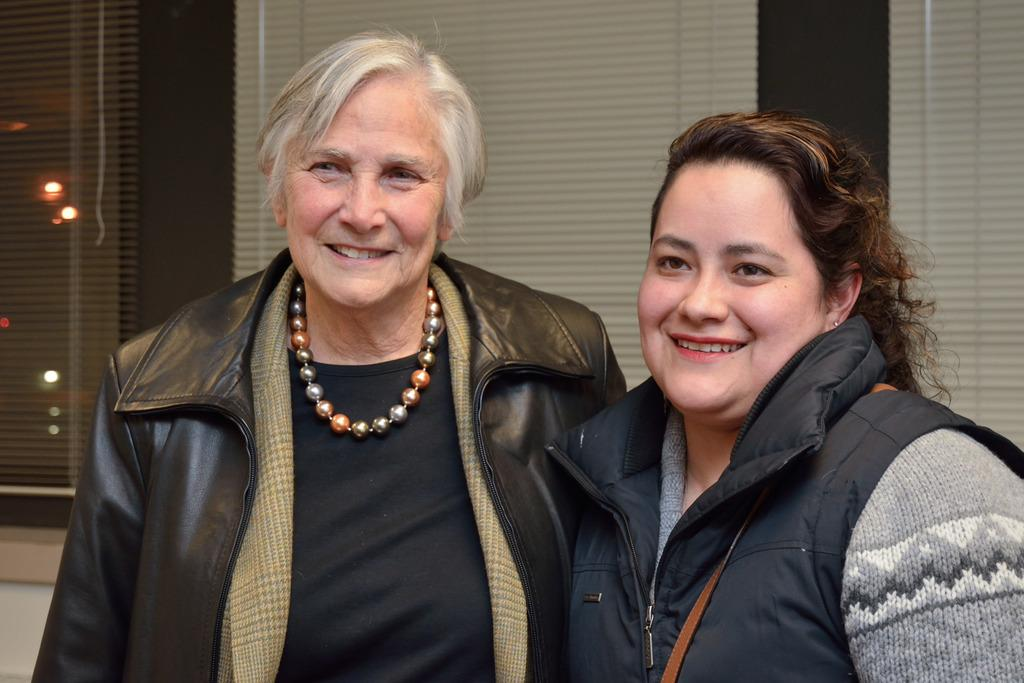How many people are in the image? There are two people in the image. What are the people doing in the image? The people are standing and smiling. What can be seen in the background of the image? There are lights visible in the image, and there are blinds or curtains hanging in the background. What type of cloth is being used to make the loaf in the image? There is no cloth or loaf present in the image. How many legs can be seen in the image? The provided facts do not mention any legs, so it is impossible to determine the number of legs visible in the image. 